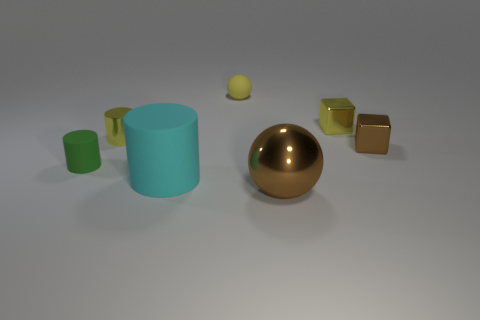Subtract all purple blocks. Subtract all gray cylinders. How many blocks are left? 2 Add 3 small metal blocks. How many objects exist? 10 Subtract all blocks. How many objects are left? 5 Add 2 yellow matte spheres. How many yellow matte spheres exist? 3 Subtract 0 gray cylinders. How many objects are left? 7 Subtract all yellow metallic cylinders. Subtract all green matte things. How many objects are left? 5 Add 3 tiny cylinders. How many tiny cylinders are left? 5 